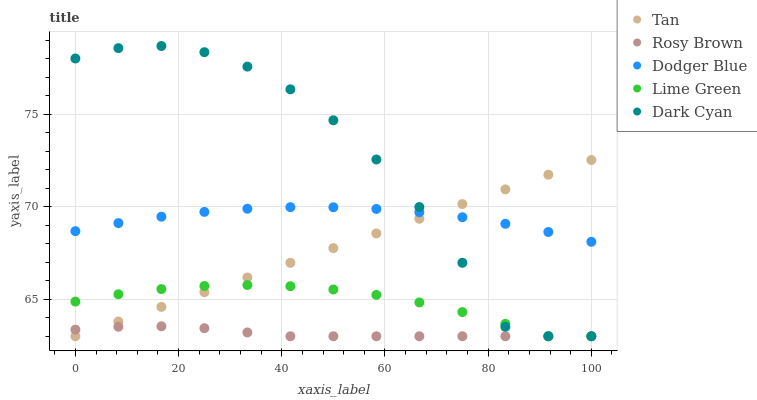Does Rosy Brown have the minimum area under the curve?
Answer yes or no. Yes. Does Dark Cyan have the maximum area under the curve?
Answer yes or no. Yes. Does Lime Green have the minimum area under the curve?
Answer yes or no. No. Does Lime Green have the maximum area under the curve?
Answer yes or no. No. Is Tan the smoothest?
Answer yes or no. Yes. Is Dark Cyan the roughest?
Answer yes or no. Yes. Is Lime Green the smoothest?
Answer yes or no. No. Is Lime Green the roughest?
Answer yes or no. No. Does Dark Cyan have the lowest value?
Answer yes or no. Yes. Does Dodger Blue have the lowest value?
Answer yes or no. No. Does Dark Cyan have the highest value?
Answer yes or no. Yes. Does Lime Green have the highest value?
Answer yes or no. No. Is Lime Green less than Dodger Blue?
Answer yes or no. Yes. Is Dodger Blue greater than Lime Green?
Answer yes or no. Yes. Does Dodger Blue intersect Tan?
Answer yes or no. Yes. Is Dodger Blue less than Tan?
Answer yes or no. No. Is Dodger Blue greater than Tan?
Answer yes or no. No. Does Lime Green intersect Dodger Blue?
Answer yes or no. No. 